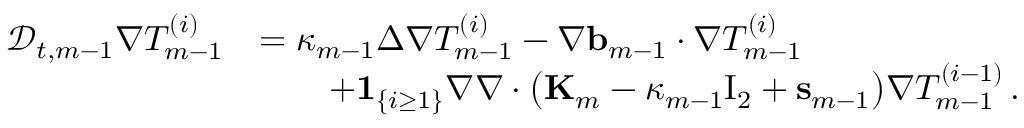Convert formula to latex. <formula><loc_0><loc_0><loc_500><loc_500>\begin{array} { r l } { \ m a t h s c r { D } _ { t , m - 1 } \nabla T _ { m - 1 } ^ { ( i ) } } & { = \kappa _ { m - 1 } \Delta \nabla T _ { m - 1 } ^ { ( i ) } - \nabla { b } _ { m - 1 } \cdot \nabla T _ { m - 1 } ^ { ( i ) } } \\ & { \quad + { 1 } _ { \{ i \geq 1 \} } \nabla \nabla \cdot \left ( K _ { m } - \kappa _ { m - 1 } { I _ { 2 } } + s _ { m - 1 } \right ) \nabla T _ { m - 1 } ^ { ( i - 1 ) } \, . } \end{array}</formula> 